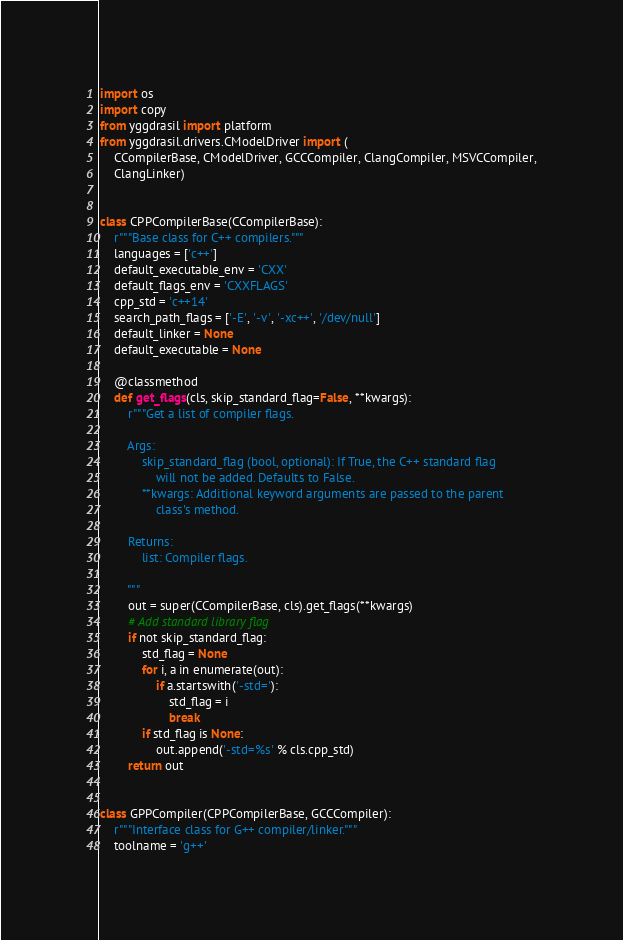<code> <loc_0><loc_0><loc_500><loc_500><_Python_>import os
import copy
from yggdrasil import platform
from yggdrasil.drivers.CModelDriver import (
    CCompilerBase, CModelDriver, GCCCompiler, ClangCompiler, MSVCCompiler,
    ClangLinker)


class CPPCompilerBase(CCompilerBase):
    r"""Base class for C++ compilers."""
    languages = ['c++']
    default_executable_env = 'CXX'
    default_flags_env = 'CXXFLAGS'
    cpp_std = 'c++14'
    search_path_flags = ['-E', '-v', '-xc++', '/dev/null']
    default_linker = None
    default_executable = None

    @classmethod
    def get_flags(cls, skip_standard_flag=False, **kwargs):
        r"""Get a list of compiler flags.

        Args:
            skip_standard_flag (bool, optional): If True, the C++ standard flag
                will not be added. Defaults to False.
            **kwargs: Additional keyword arguments are passed to the parent
                class's method.

        Returns:
            list: Compiler flags.

        """
        out = super(CCompilerBase, cls).get_flags(**kwargs)
        # Add standard library flag
        if not skip_standard_flag:
            std_flag = None
            for i, a in enumerate(out):
                if a.startswith('-std='):
                    std_flag = i
                    break
            if std_flag is None:
                out.append('-std=%s' % cls.cpp_std)
        return out
    

class GPPCompiler(CPPCompilerBase, GCCCompiler):
    r"""Interface class for G++ compiler/linker."""
    toolname = 'g++'</code> 